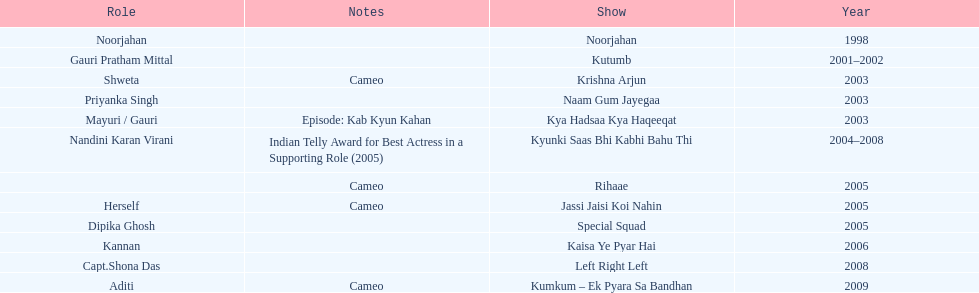Besides rihaae, in what other show did gauri tejwani cameo in 2005? Jassi Jaisi Koi Nahin. 